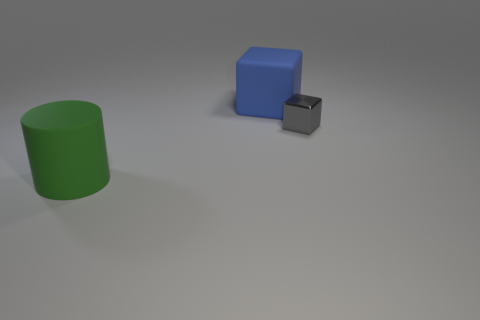Add 1 large cubes. How many objects exist? 4 Subtract all cylinders. How many objects are left? 2 Subtract 0 cyan blocks. How many objects are left? 3 Subtract all tiny blue blocks. Subtract all big blue rubber cubes. How many objects are left? 2 Add 2 green cylinders. How many green cylinders are left? 3 Add 3 large red matte cylinders. How many large red matte cylinders exist? 3 